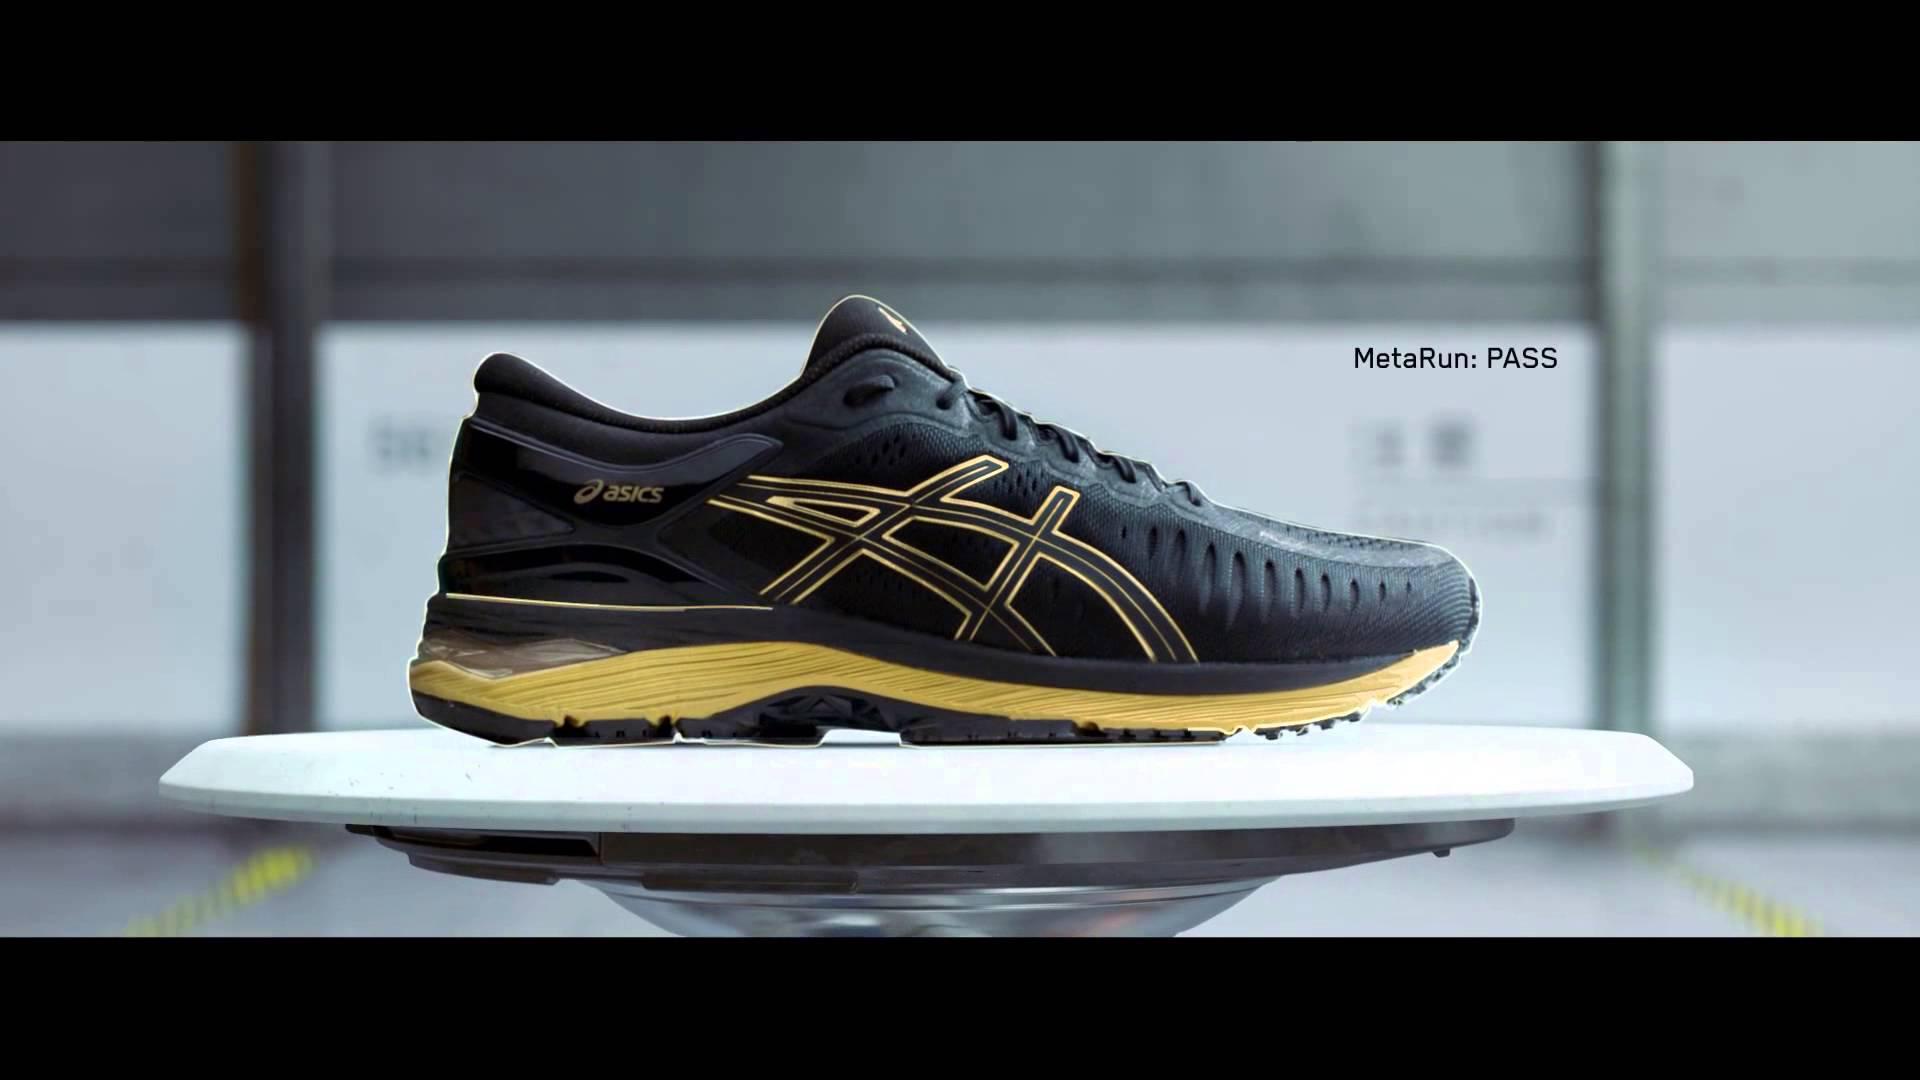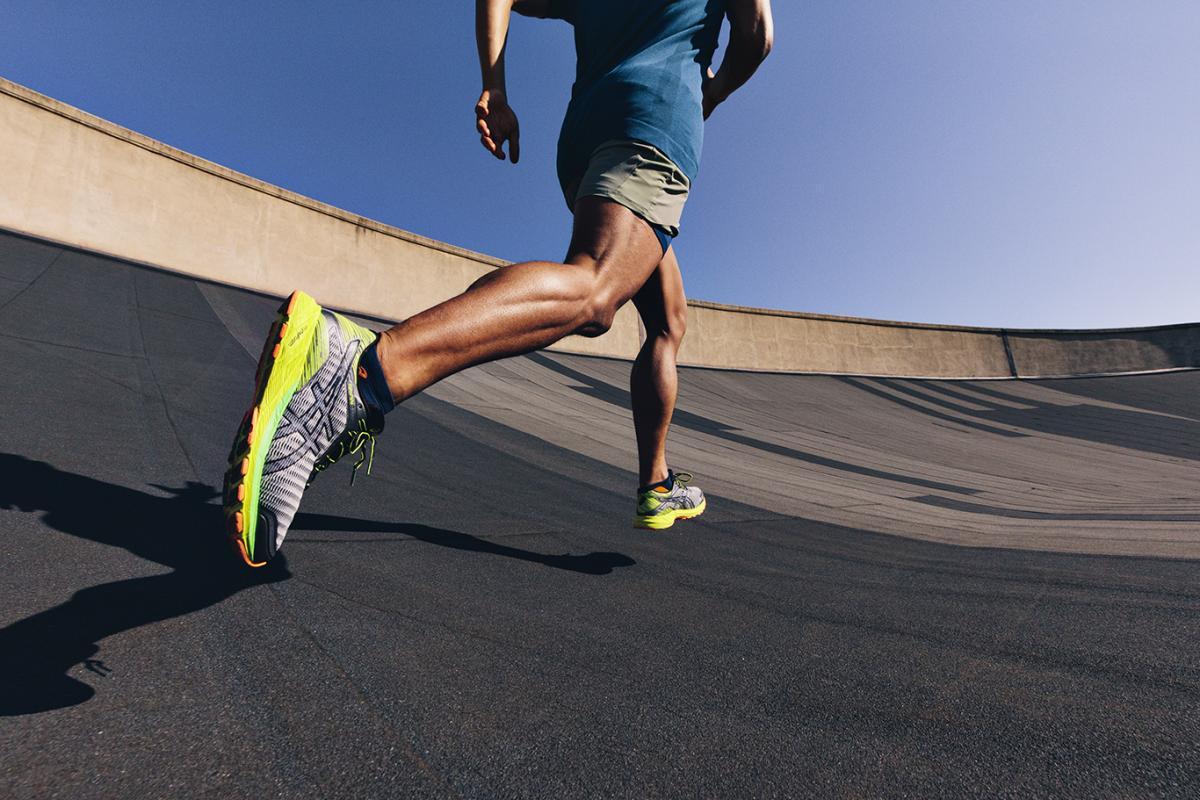The first image is the image on the left, the second image is the image on the right. For the images displayed, is the sentence "There is a running shoe presented by a robotic arm in at least one of the images." factually correct? Answer yes or no. No. 